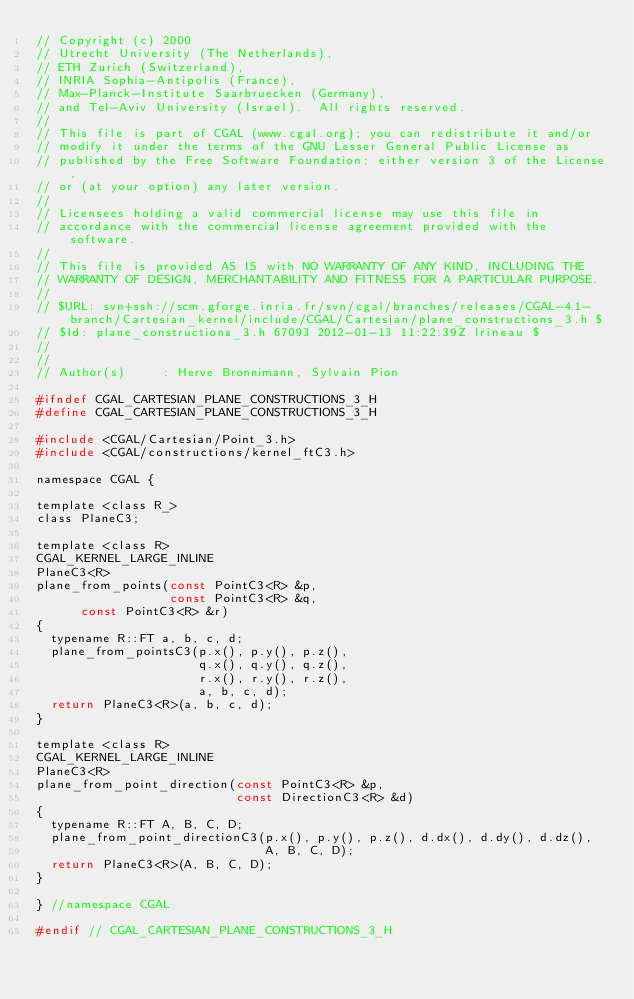<code> <loc_0><loc_0><loc_500><loc_500><_C_>// Copyright (c) 2000  
// Utrecht University (The Netherlands),
// ETH Zurich (Switzerland),
// INRIA Sophia-Antipolis (France),
// Max-Planck-Institute Saarbruecken (Germany),
// and Tel-Aviv University (Israel).  All rights reserved. 
//
// This file is part of CGAL (www.cgal.org); you can redistribute it and/or
// modify it under the terms of the GNU Lesser General Public License as
// published by the Free Software Foundation; either version 3 of the License,
// or (at your option) any later version.
//
// Licensees holding a valid commercial license may use this file in
// accordance with the commercial license agreement provided with the software.
//
// This file is provided AS IS with NO WARRANTY OF ANY KIND, INCLUDING THE
// WARRANTY OF DESIGN, MERCHANTABILITY AND FITNESS FOR A PARTICULAR PURPOSE.
//
// $URL: svn+ssh://scm.gforge.inria.fr/svn/cgal/branches/releases/CGAL-4.1-branch/Cartesian_kernel/include/CGAL/Cartesian/plane_constructions_3.h $
// $Id: plane_constructions_3.h 67093 2012-01-13 11:22:39Z lrineau $
// 
//
// Author(s)     : Herve Bronnimann, Sylvain Pion

#ifndef CGAL_CARTESIAN_PLANE_CONSTRUCTIONS_3_H
#define CGAL_CARTESIAN_PLANE_CONSTRUCTIONS_3_H

#include <CGAL/Cartesian/Point_3.h>
#include <CGAL/constructions/kernel_ftC3.h>

namespace CGAL {

template <class R_>
class PlaneC3;

template <class R>
CGAL_KERNEL_LARGE_INLINE
PlaneC3<R>
plane_from_points(const PointC3<R> &p,
                  const PointC3<R> &q,
		  const PointC3<R> &r)
{
  typename R::FT a, b, c, d;
  plane_from_pointsC3(p.x(), p.y(), p.z(),
                      q.x(), q.y(), q.z(),
                      r.x(), r.y(), r.z(),
                      a, b, c, d);
  return PlaneC3<R>(a, b, c, d);
}

template <class R>
CGAL_KERNEL_LARGE_INLINE
PlaneC3<R>
plane_from_point_direction(const PointC3<R> &p,
                           const DirectionC3<R> &d)
{
  typename R::FT A, B, C, D;
  plane_from_point_directionC3(p.x(), p.y(), p.z(), d.dx(), d.dy(), d.dz(),
                               A, B, C, D);
  return PlaneC3<R>(A, B, C, D);
}

} //namespace CGAL

#endif // CGAL_CARTESIAN_PLANE_CONSTRUCTIONS_3_H
</code> 